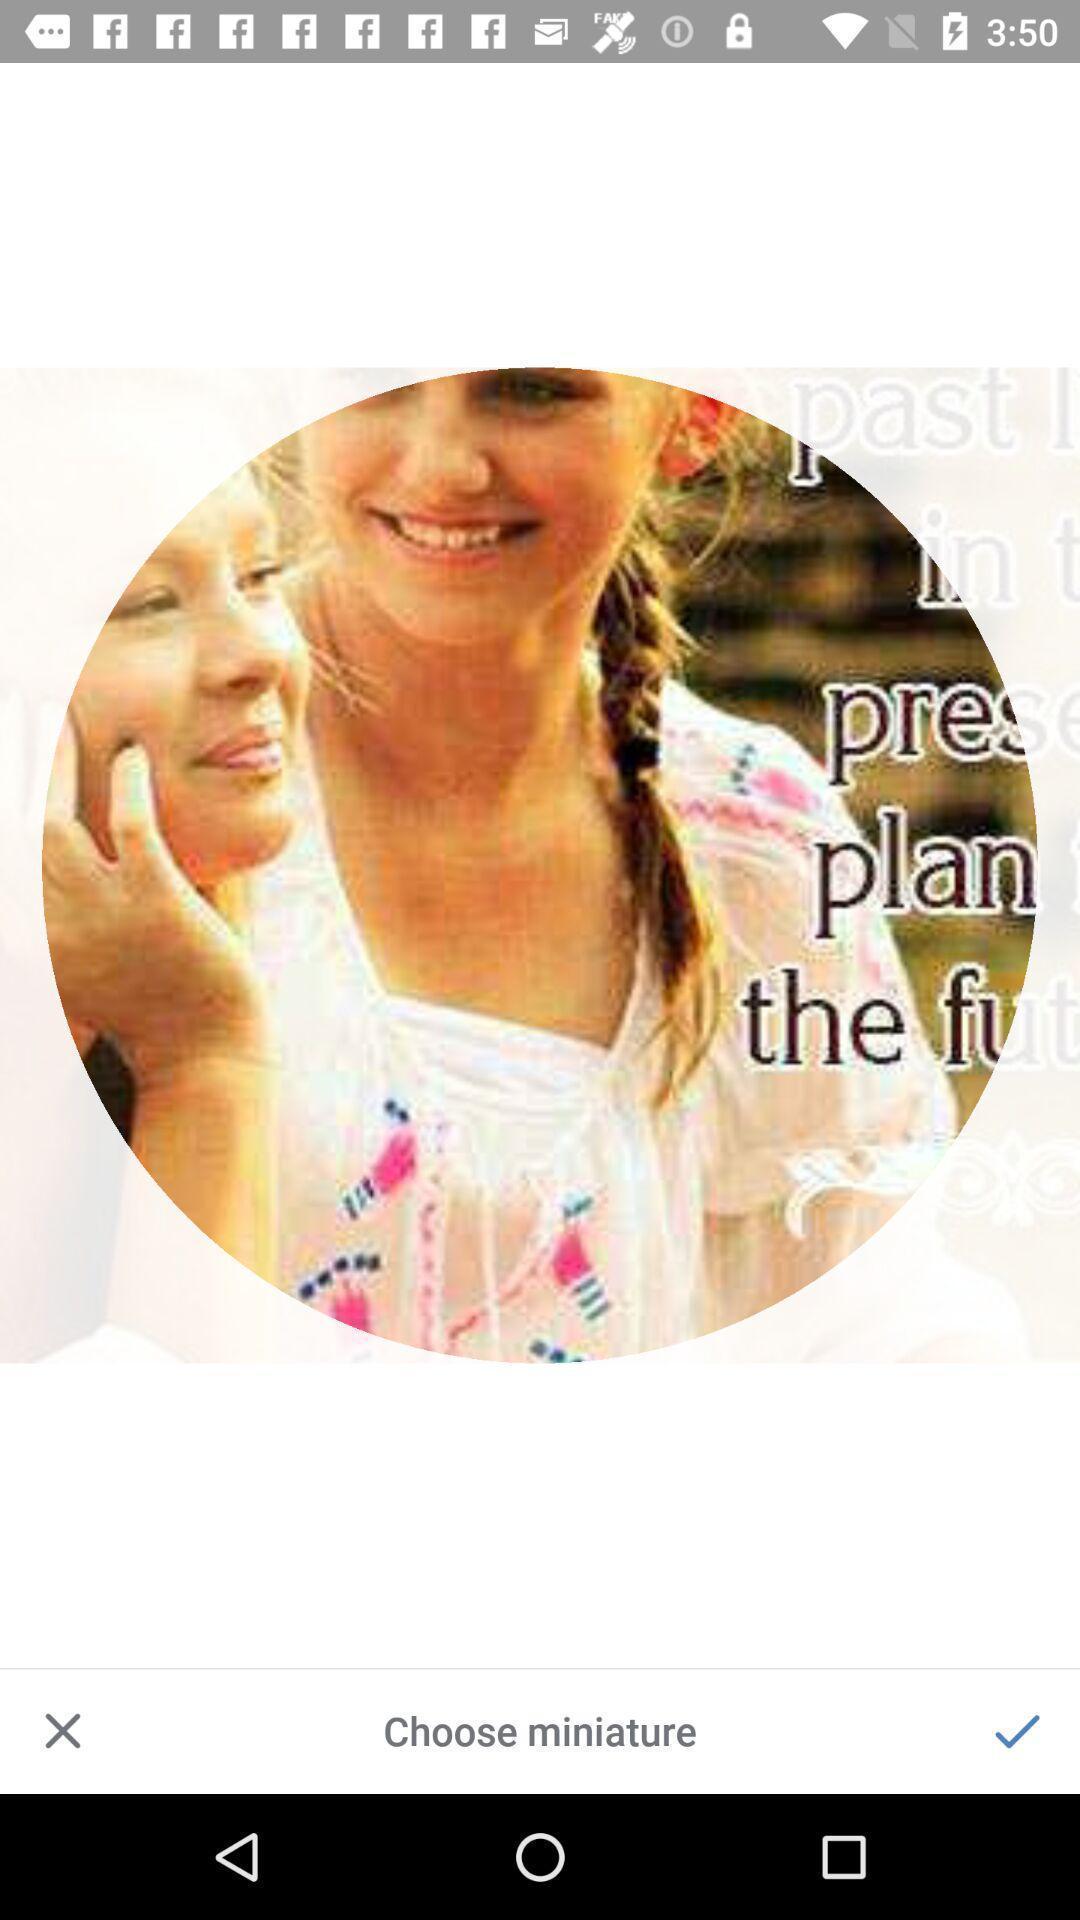Explain the elements present in this screenshot. Uploading profile page of a social app. 